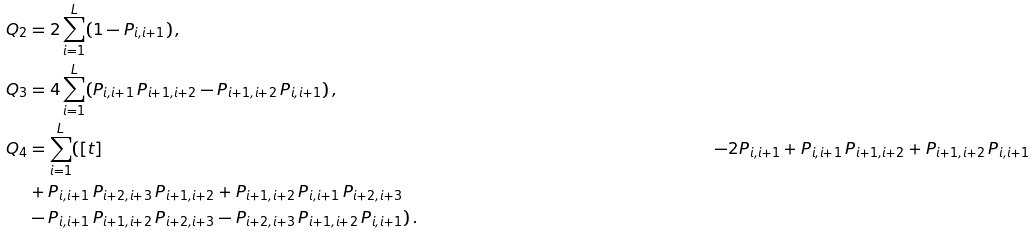<formula> <loc_0><loc_0><loc_500><loc_500>Q _ { 2 } & = 2 \sum _ { i = 1 } ^ { L } ( 1 - P _ { i , i + 1 } ) \, , \\ Q _ { 3 } & = 4 \sum _ { i = 1 } ^ { L } ( P _ { i , i + 1 } \, P _ { i + 1 , i + 2 } - P _ { i + 1 , i + 2 } \, P _ { i , i + 1 } ) \, , \\ Q _ { 4 } & = \sum _ { i = 1 } ^ { L } ( [ t ] & - 2 P _ { i , i + 1 } + P _ { i , i + 1 } \, P _ { i + 1 , i + 2 } + P _ { i + 1 , i + 2 } \, P _ { i , i + 1 } \\ & + P _ { i , i + 1 } \, P _ { i + 2 , i + 3 } \, P _ { i + 1 , i + 2 } + P _ { i + 1 , i + 2 } \, P _ { i , i + 1 } \, P _ { i + 2 , i + 3 } \\ & - P _ { i , i + 1 } \, P _ { i + 1 , i + 2 } \, P _ { i + 2 , i + 3 } - P _ { i + 2 , i + 3 } \, P _ { i + 1 , i + 2 } \, P _ { i , i + 1 } ) \, .</formula> 